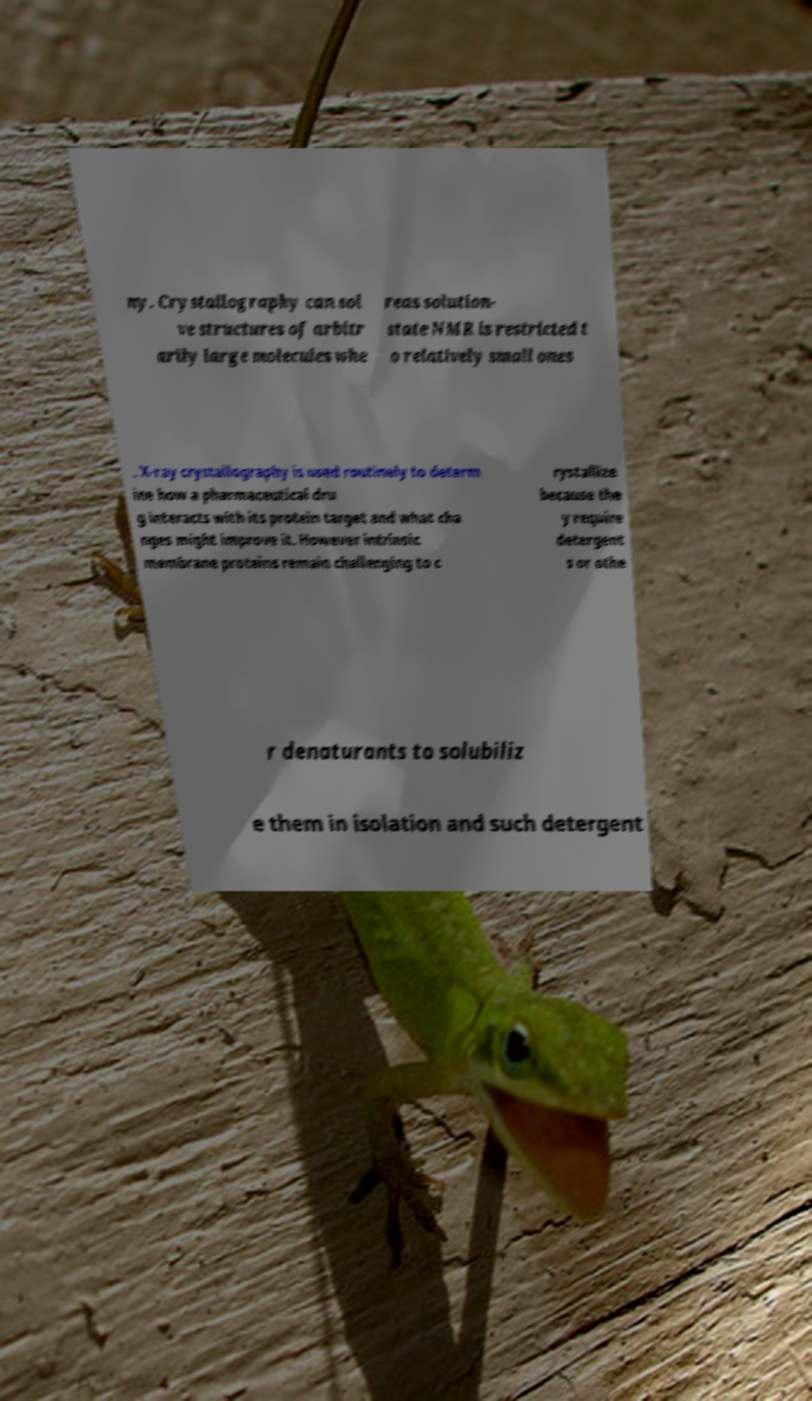Can you accurately transcribe the text from the provided image for me? ny. Crystallography can sol ve structures of arbitr arily large molecules whe reas solution- state NMR is restricted t o relatively small ones . X-ray crystallography is used routinely to determ ine how a pharmaceutical dru g interacts with its protein target and what cha nges might improve it. However intrinsic membrane proteins remain challenging to c rystallize because the y require detergent s or othe r denaturants to solubiliz e them in isolation and such detergent 